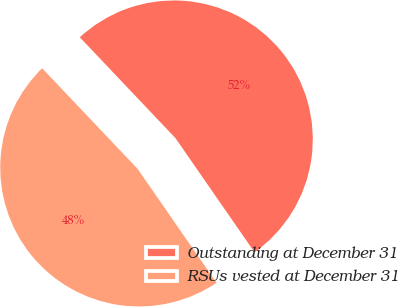Convert chart to OTSL. <chart><loc_0><loc_0><loc_500><loc_500><pie_chart><fcel>Outstanding at December 31<fcel>RSUs vested at December 31<nl><fcel>52.44%<fcel>47.56%<nl></chart> 